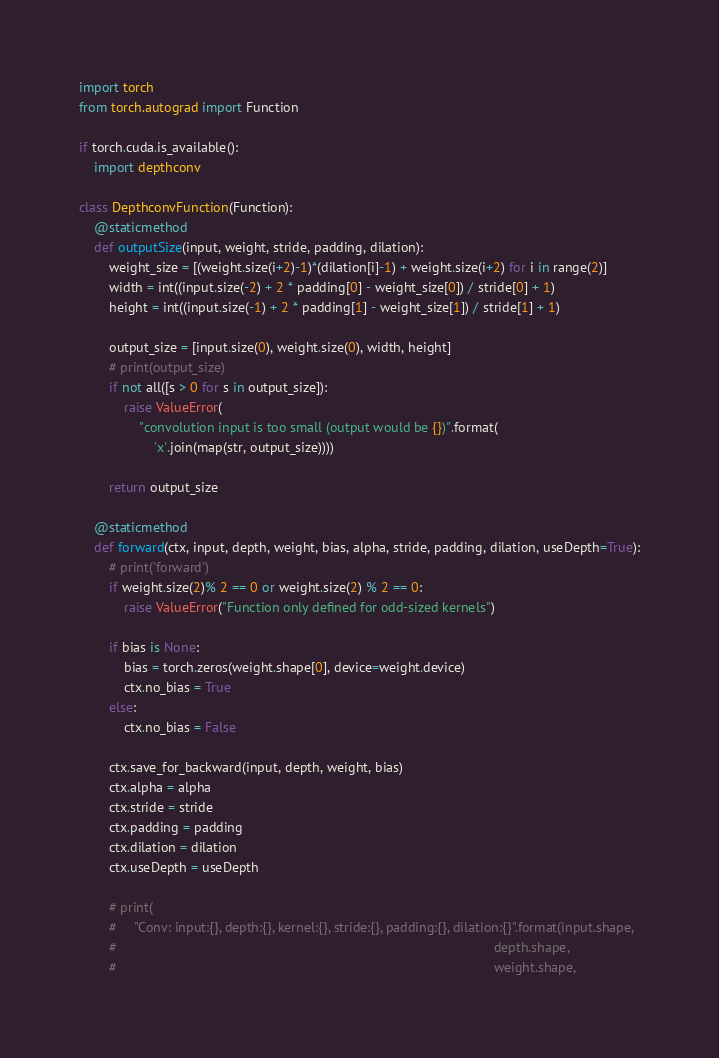<code> <loc_0><loc_0><loc_500><loc_500><_Python_>import torch
from torch.autograd import Function

if torch.cuda.is_available():
    import depthconv

class DepthconvFunction(Function):
    @staticmethod
    def outputSize(input, weight, stride, padding, dilation):
        weight_size = [(weight.size(i+2)-1)*(dilation[i]-1) + weight.size(i+2) for i in range(2)]
        width = int((input.size(-2) + 2 * padding[0] - weight_size[0]) / stride[0] + 1)
        height = int((input.size(-1) + 2 * padding[1] - weight_size[1]) / stride[1] + 1)

        output_size = [input.size(0), weight.size(0), width, height]
        # print(output_size)
        if not all([s > 0 for s in output_size]):
            raise ValueError(
                "convolution input is too small (output would be {})".format(
                    'x'.join(map(str, output_size))))

        return output_size

    @staticmethod
    def forward(ctx, input, depth, weight, bias, alpha, stride, padding, dilation, useDepth=True):
        # print('forward')
        if weight.size(2)% 2 == 0 or weight.size(2) % 2 == 0:
            raise ValueError("Function only defined for odd-sized kernels")

        if bias is None:
            bias = torch.zeros(weight.shape[0], device=weight.device)
            ctx.no_bias = True
        else:
            ctx.no_bias = False

        ctx.save_for_backward(input, depth, weight, bias)
        ctx.alpha = alpha
        ctx.stride = stride
        ctx.padding = padding
        ctx.dilation = dilation
        ctx.useDepth = useDepth

        # print(
        #     "Conv: input:{}, depth:{}, kernel:{}, stride:{}, padding:{}, dilation:{}".format(input.shape,
        #                                                                                                     depth.shape,
        #                                                                                                     weight.shape,</code> 